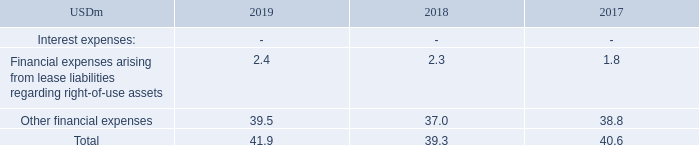NOTE 7 - continued
Lease payments not recognized as a liability The Group has elected not to recognize a lease liability for short-term leases (leases of an expected term of 12 months or less) or for leases of low value assets. Payments made under such leases are expensed on a straight-line basis. The expenses relating to payments not recognized as a lease liability are insignificant.
Administrative expenses The total outflow for leases, USD 2.9m, is presented as “Depreciation” of USD 2.5m and “Financial expenses” (interest) of USD 0.4m, in contrast to the recording of an operating lease charge of a materially equivalent figure within the line item “Administrative expenses” under IAS 17.
Financial expenses
Financial expenses for the reporting periods:
In which year was the amount of other financial expenses the largest? 39.5>38.8>37.0
Answer: 2019. What was the change in the total financial expenses in 2019 from 2018?
Answer scale should be: million. 41.9-39.3
Answer: 2.6. What was the percentage change in the total financial expenses in 2019 from 2018?
Answer scale should be: percent. (41.9-39.3)/39.3
Answer: 6.62. What does the table show? Financial expenses for the reporting periods. What is the total amount of financial expenses in 2019?
Answer scale should be: million. 41.9. What are the financial expenses under Interest Expenses in the table? Financial expenses arising from lease liabilities regarding right-of-use assets, other financial expenses. 